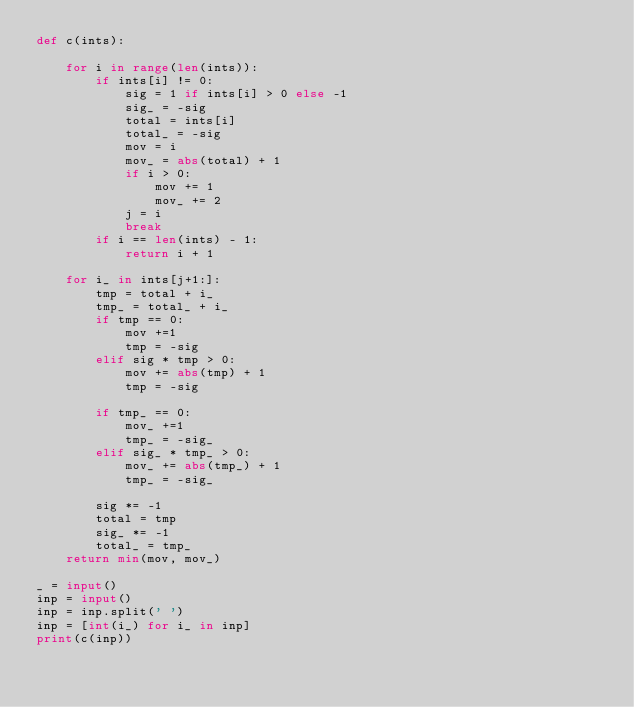<code> <loc_0><loc_0><loc_500><loc_500><_Python_>def c(ints):
    
    for i in range(len(ints)):
        if ints[i] != 0:
            sig = 1 if ints[i] > 0 else -1
            sig_ = -sig
            total = ints[i]
            total_ = -sig
            mov = i
            mov_ = abs(total) + 1
            if i > 0:
                mov += 1
                mov_ += 2
            j = i
            break
        if i == len(ints) - 1:
            return i + 1
    
    for i_ in ints[j+1:]:
        tmp = total + i_
        tmp_ = total_ + i_
        if tmp == 0:
            mov +=1
            tmp = -sig
        elif sig * tmp > 0:
            mov += abs(tmp) + 1
            tmp = -sig
            
        if tmp_ == 0:
            mov_ +=1
            tmp_ = -sig_
        elif sig_ * tmp_ > 0:
            mov_ += abs(tmp_) + 1
            tmp_ = -sig_
            
        sig *= -1
        total = tmp
        sig_ *= -1
        total_ = tmp_
    return min(mov, mov_)

_ = input()
inp = input()
inp = inp.split(' ')
inp = [int(i_) for i_ in inp]
print(c(inp))</code> 